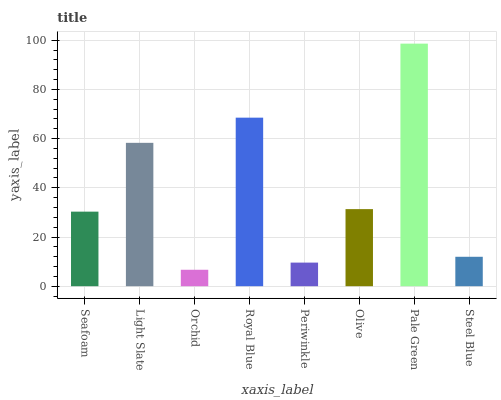Is Orchid the minimum?
Answer yes or no. Yes. Is Pale Green the maximum?
Answer yes or no. Yes. Is Light Slate the minimum?
Answer yes or no. No. Is Light Slate the maximum?
Answer yes or no. No. Is Light Slate greater than Seafoam?
Answer yes or no. Yes. Is Seafoam less than Light Slate?
Answer yes or no. Yes. Is Seafoam greater than Light Slate?
Answer yes or no. No. Is Light Slate less than Seafoam?
Answer yes or no. No. Is Olive the high median?
Answer yes or no. Yes. Is Seafoam the low median?
Answer yes or no. Yes. Is Royal Blue the high median?
Answer yes or no. No. Is Steel Blue the low median?
Answer yes or no. No. 